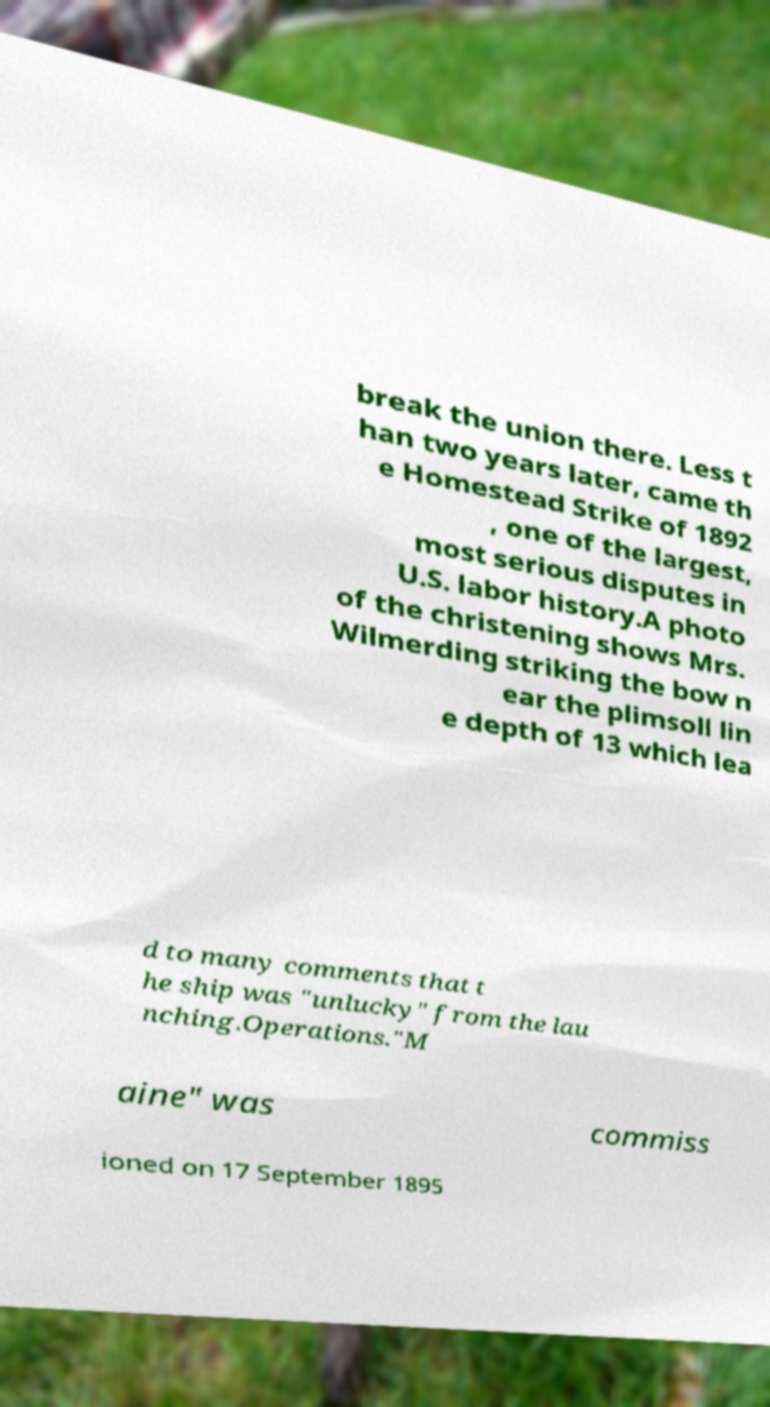Can you read and provide the text displayed in the image?This photo seems to have some interesting text. Can you extract and type it out for me? break the union there. Less t han two years later, came th e Homestead Strike of 1892 , one of the largest, most serious disputes in U.S. labor history.A photo of the christening shows Mrs. Wilmerding striking the bow n ear the plimsoll lin e depth of 13 which lea d to many comments that t he ship was "unlucky" from the lau nching.Operations."M aine" was commiss ioned on 17 September 1895 